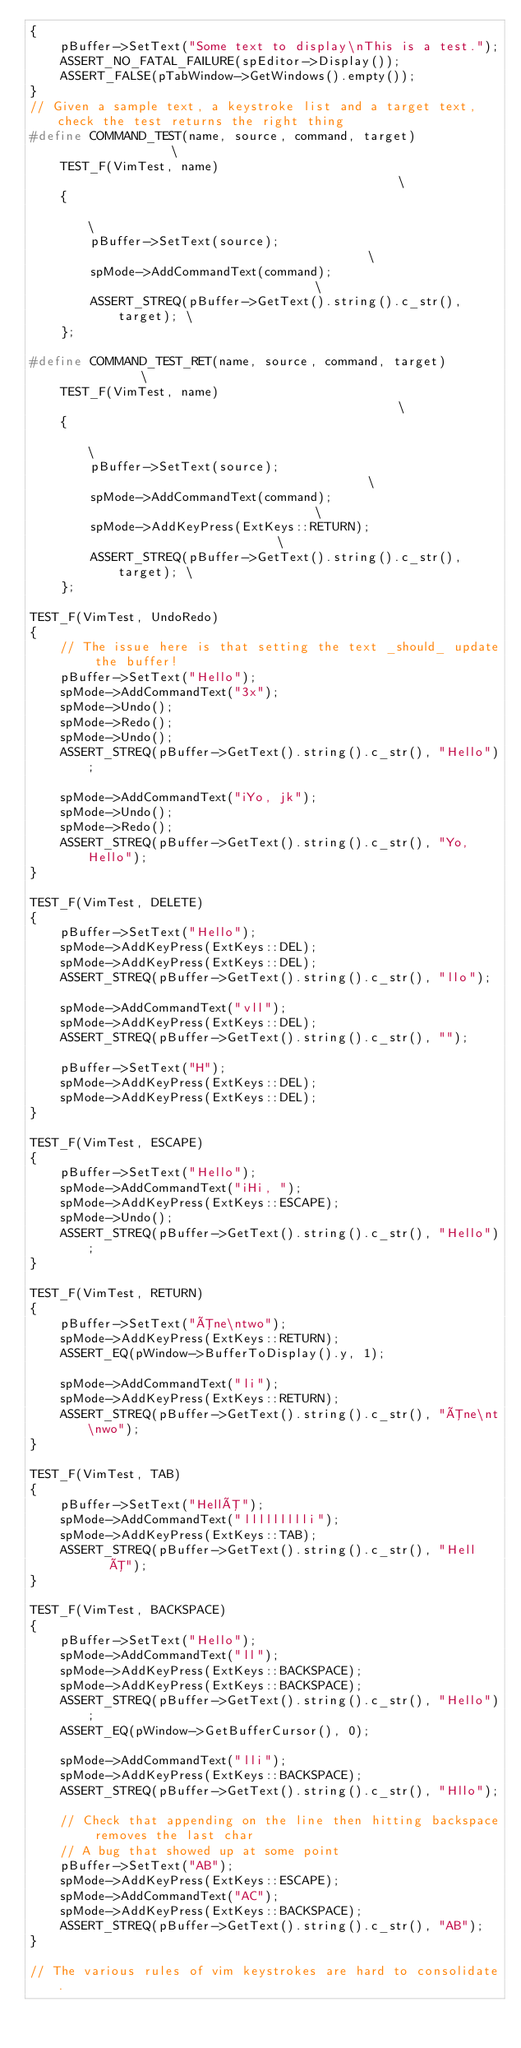<code> <loc_0><loc_0><loc_500><loc_500><_C++_>{
    pBuffer->SetText("Some text to display\nThis is a test.");
    ASSERT_NO_FATAL_FAILURE(spEditor->Display());
    ASSERT_FALSE(pTabWindow->GetWindows().empty());
}
// Given a sample text, a keystroke list and a target text, check the test returns the right thing
#define COMMAND_TEST(name, source, command, target)                \
    TEST_F(VimTest, name)                                          \
    {                                                              \
        pBuffer->SetText(source);                                  \
        spMode->AddCommandText(command);                           \
        ASSERT_STREQ(pBuffer->GetText().string().c_str(), target); \
    };

#define COMMAND_TEST_RET(name, source, command, target)            \
    TEST_F(VimTest, name)                                          \
    {                                                              \
        pBuffer->SetText(source);                                  \
        spMode->AddCommandText(command);                           \
        spMode->AddKeyPress(ExtKeys::RETURN);                      \
        ASSERT_STREQ(pBuffer->GetText().string().c_str(), target); \
    };

TEST_F(VimTest, UndoRedo)
{
    // The issue here is that setting the text _should_ update the buffer!
    pBuffer->SetText("Hello");
    spMode->AddCommandText("3x");
    spMode->Undo();
    spMode->Redo();
    spMode->Undo();
    ASSERT_STREQ(pBuffer->GetText().string().c_str(), "Hello");

    spMode->AddCommandText("iYo, jk");
    spMode->Undo();
    spMode->Redo();
    ASSERT_STREQ(pBuffer->GetText().string().c_str(), "Yo, Hello");
}

TEST_F(VimTest, DELETE)
{
    pBuffer->SetText("Hello");
    spMode->AddKeyPress(ExtKeys::DEL);
    spMode->AddKeyPress(ExtKeys::DEL);
    ASSERT_STREQ(pBuffer->GetText().string().c_str(), "llo");

    spMode->AddCommandText("vll");
    spMode->AddKeyPress(ExtKeys::DEL);
    ASSERT_STREQ(pBuffer->GetText().string().c_str(), "");

    pBuffer->SetText("H");
    spMode->AddKeyPress(ExtKeys::DEL);
    spMode->AddKeyPress(ExtKeys::DEL);
}

TEST_F(VimTest, ESCAPE)
{
    pBuffer->SetText("Hello");
    spMode->AddCommandText("iHi, ");
    spMode->AddKeyPress(ExtKeys::ESCAPE);
    spMode->Undo();
    ASSERT_STREQ(pBuffer->GetText().string().c_str(), "Hello");
}

TEST_F(VimTest, RETURN)
{
    pBuffer->SetText("Õne\ntwo");
    spMode->AddKeyPress(ExtKeys::RETURN);
    ASSERT_EQ(pWindow->BufferToDisplay().y, 1);

    spMode->AddCommandText("li");
    spMode->AddKeyPress(ExtKeys::RETURN);
    ASSERT_STREQ(pBuffer->GetText().string().c_str(), "Õne\nt\nwo");
}

TEST_F(VimTest, TAB)
{
    pBuffer->SetText("HellÕ");
    spMode->AddCommandText("llllllllli");
    spMode->AddKeyPress(ExtKeys::TAB);
    ASSERT_STREQ(pBuffer->GetText().string().c_str(), "Hell    Õ");
}

TEST_F(VimTest, BACKSPACE)
{
    pBuffer->SetText("Hello");
    spMode->AddCommandText("ll");
    spMode->AddKeyPress(ExtKeys::BACKSPACE);
    spMode->AddKeyPress(ExtKeys::BACKSPACE);
    ASSERT_STREQ(pBuffer->GetText().string().c_str(), "Hello");
    ASSERT_EQ(pWindow->GetBufferCursor(), 0);

    spMode->AddCommandText("lli");
    spMode->AddKeyPress(ExtKeys::BACKSPACE);
    ASSERT_STREQ(pBuffer->GetText().string().c_str(), "Hllo");

    // Check that appending on the line then hitting backspace removes the last char
    // A bug that showed up at some point
    pBuffer->SetText("AB");
    spMode->AddKeyPress(ExtKeys::ESCAPE);
    spMode->AddCommandText("AC");
    spMode->AddKeyPress(ExtKeys::BACKSPACE);
    ASSERT_STREQ(pBuffer->GetText().string().c_str(), "AB");
}

// The various rules of vim keystrokes are hard to consolidate.</code> 